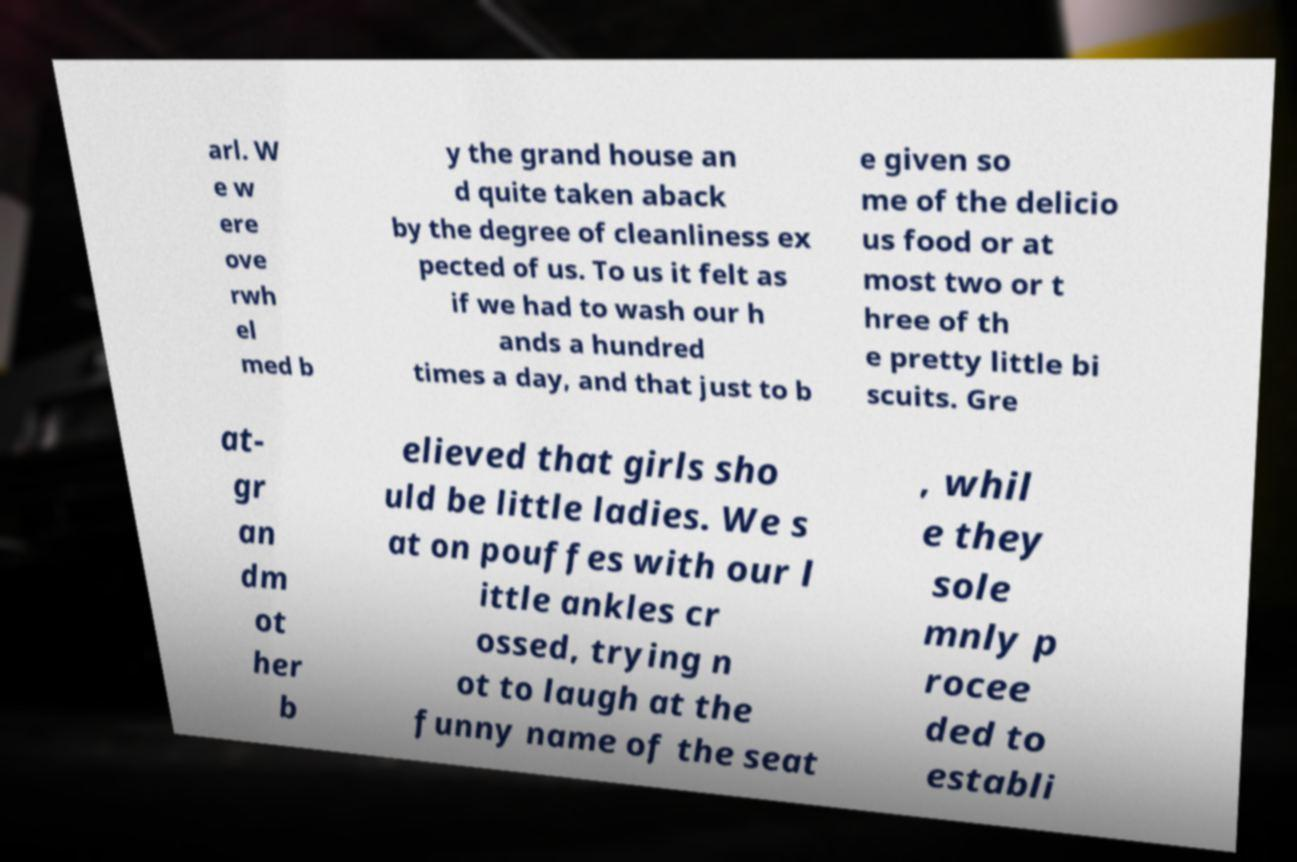Please read and relay the text visible in this image. What does it say? arl. W e w ere ove rwh el med b y the grand house an d quite taken aback by the degree of cleanliness ex pected of us. To us it felt as if we had to wash our h ands a hundred times a day, and that just to b e given so me of the delicio us food or at most two or t hree of th e pretty little bi scuits. Gre at- gr an dm ot her b elieved that girls sho uld be little ladies. We s at on pouffes with our l ittle ankles cr ossed, trying n ot to laugh at the funny name of the seat , whil e they sole mnly p rocee ded to establi 